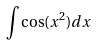Convert formula to latex. <formula><loc_0><loc_0><loc_500><loc_500>\int \cos ( x ^ { 2 } ) d x</formula> 